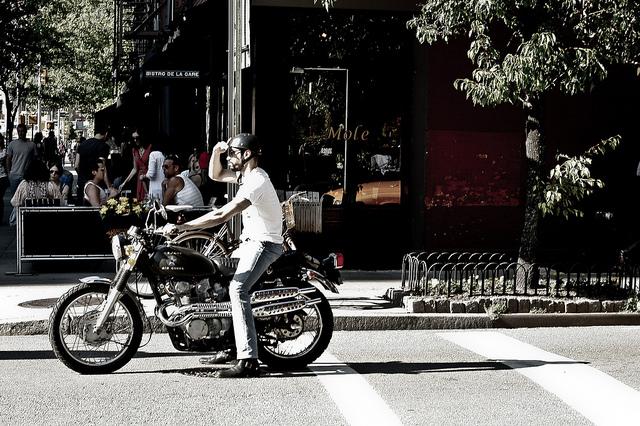How many people are on the motorcycle?
Keep it brief. 1. Do you think that this is an expensive motorcycle?
Keep it brief. No. Is the tree fenced in?
Quick response, please. Yes. What is in the background?
Quick response, please. Restaurant. 